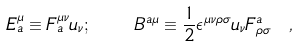Convert formula to latex. <formula><loc_0><loc_0><loc_500><loc_500>E _ { a } ^ { \mu } \equiv F ^ { \mu \nu } _ { a } u _ { \nu } ; \quad B ^ { a \mu } \equiv \frac { 1 } { 2 } \epsilon ^ { \mu \nu \rho \sigma } u _ { \nu } F ^ { a } _ { \rho \sigma } \ ,</formula> 